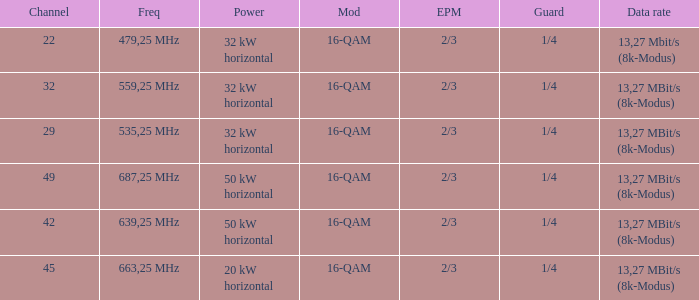On channel 32, when the power is 32 kW horizontal, what is the modulation? 16-QAM. 